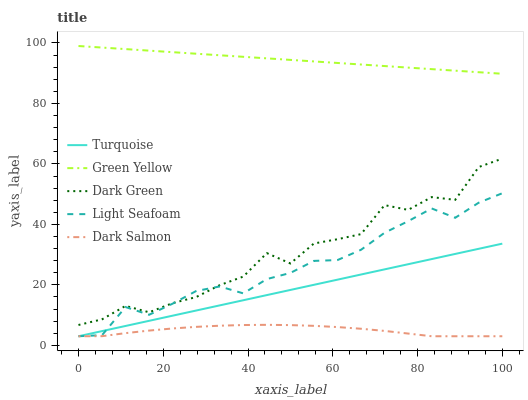Does Dark Salmon have the minimum area under the curve?
Answer yes or no. Yes. Does Green Yellow have the maximum area under the curve?
Answer yes or no. Yes. Does Green Yellow have the minimum area under the curve?
Answer yes or no. No. Does Dark Salmon have the maximum area under the curve?
Answer yes or no. No. Is Turquoise the smoothest?
Answer yes or no. Yes. Is Dark Green the roughest?
Answer yes or no. Yes. Is Green Yellow the smoothest?
Answer yes or no. No. Is Green Yellow the roughest?
Answer yes or no. No. Does Green Yellow have the lowest value?
Answer yes or no. No. Does Dark Salmon have the highest value?
Answer yes or no. No. Is Turquoise less than Green Yellow?
Answer yes or no. Yes. Is Green Yellow greater than Dark Green?
Answer yes or no. Yes. Does Turquoise intersect Green Yellow?
Answer yes or no. No. 